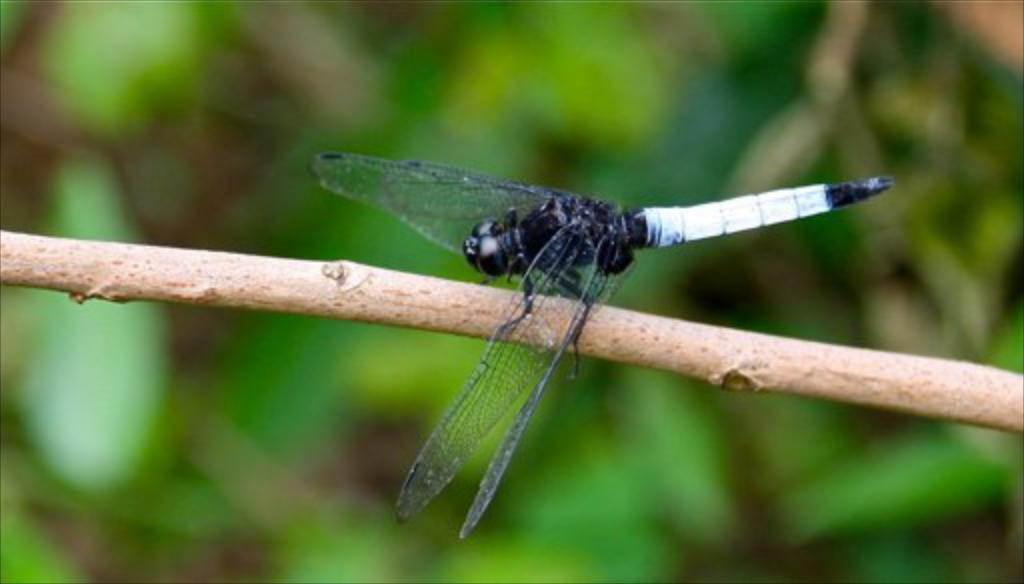What is present in the image? There is an insect in the image. Where is the insect located? The insect is on the stem of a plant. What type of yak can be seen coughing in the image? There is no yak present in the image, nor is there any coughing. 